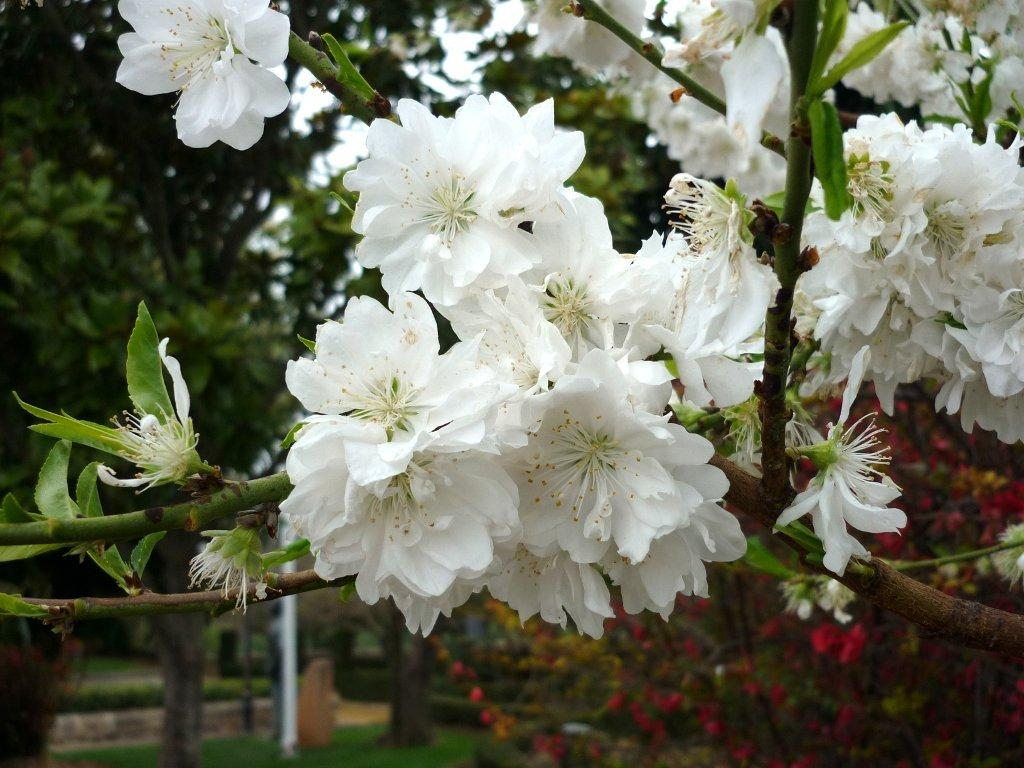What type of plant is visible in the image? There is a plant with flowers in the image. What can be seen in the background of the image? There are trees, a pole, and plants with flowers in the background of the image. What part of the natural environment is visible in the image? The sky is visible in the background of the image. What type of punishment is being administered to the snail in the image? There is no snail present in the image, and therefore no punishment is being administered. 